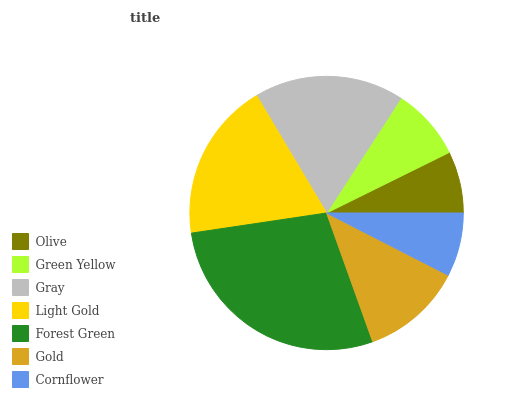Is Olive the minimum?
Answer yes or no. Yes. Is Forest Green the maximum?
Answer yes or no. Yes. Is Green Yellow the minimum?
Answer yes or no. No. Is Green Yellow the maximum?
Answer yes or no. No. Is Green Yellow greater than Olive?
Answer yes or no. Yes. Is Olive less than Green Yellow?
Answer yes or no. Yes. Is Olive greater than Green Yellow?
Answer yes or no. No. Is Green Yellow less than Olive?
Answer yes or no. No. Is Gold the high median?
Answer yes or no. Yes. Is Gold the low median?
Answer yes or no. Yes. Is Green Yellow the high median?
Answer yes or no. No. Is Gray the low median?
Answer yes or no. No. 